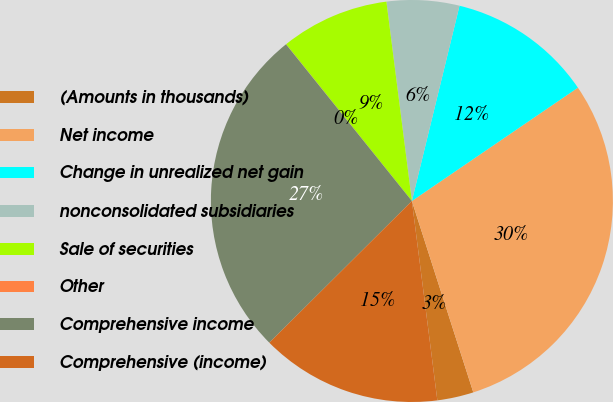<chart> <loc_0><loc_0><loc_500><loc_500><pie_chart><fcel>(Amounts in thousands)<fcel>Net income<fcel>Change in unrealized net gain<fcel>nonconsolidated subsidiaries<fcel>Sale of securities<fcel>Other<fcel>Comprehensive income<fcel>Comprehensive (income)<nl><fcel>2.92%<fcel>29.59%<fcel>11.66%<fcel>5.83%<fcel>8.74%<fcel>0.01%<fcel>26.68%<fcel>14.57%<nl></chart> 